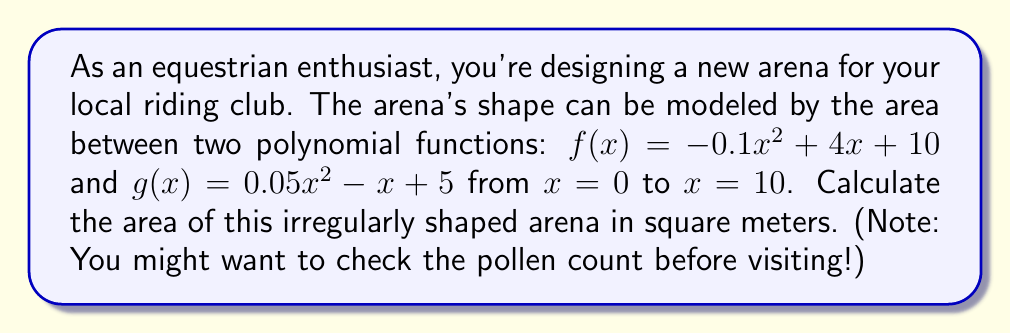Can you solve this math problem? To find the area of the irregularly shaped arena, we need to calculate the area between the two polynomial functions. This can be done using definite integrals.

1) The area between two functions is given by:
   $$A = \int_a^b [f(x) - g(x)] dx$$
   where $f(x)$ is the upper function and $g(x)$ is the lower function.

2) In this case:
   $f(x) = -0.1x^2 + 4x + 10$
   $g(x) = 0.05x^2 - x + 5$
   $a = 0$ and $b = 10$

3) Let's subtract $g(x)$ from $f(x)$:
   $$f(x) - g(x) = (-0.1x^2 + 4x + 10) - (0.05x^2 - x + 5)$$
   $$= -0.15x^2 + 5x + 5$$

4) Now we can set up our integral:
   $$A = \int_0^{10} (-0.15x^2 + 5x + 5) dx$$

5) Integrate the polynomial:
   $$A = [-0.05x^3 + 2.5x^2 + 5x]_0^{10}$$

6) Evaluate the integral:
   $$A = [-0.05(10^3) + 2.5(10^2) + 5(10)] - [-0.05(0^3) + 2.5(0^2) + 5(0)]$$
   $$= [-50 + 250 + 50] - [0]$$
   $$= 250$$

Therefore, the area of the irregularly shaped arena is 250 square meters.
Answer: 250 square meters 